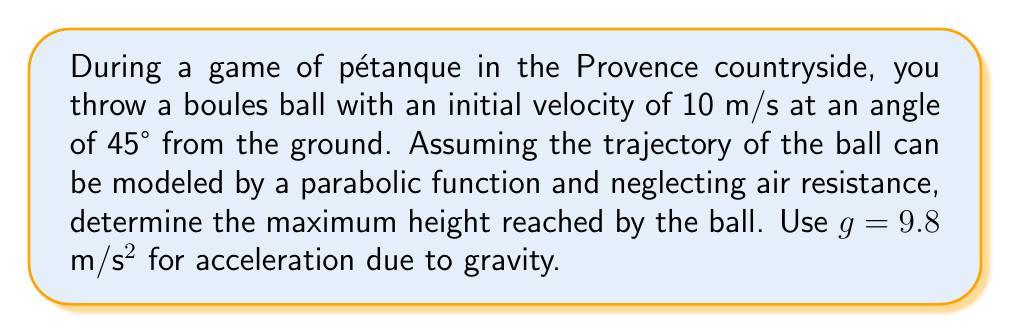Could you help me with this problem? Let's approach this step-by-step:

1) The trajectory of a projectile (like our boules ball) can be described by a parabolic function in the form:

   $$y = -\frac{1}{2}g(\frac{x}{v_x})^2 + \tan(\theta)x + h_0$$

   Where:
   - $y$ is the vertical position
   - $x$ is the horizontal position
   - $g$ is the acceleration due to gravity (9.8 m/s²)
   - $v_x$ is the initial horizontal velocity
   - $\theta$ is the launch angle
   - $h_0$ is the initial height (in this case, 0)

2) We're given:
   - Initial velocity $v = 10$ m/s
   - Launch angle $\theta = 45°$
   - $g = 9.8$ m/s²

3) First, let's calculate the initial horizontal velocity $v_x$:
   $$v_x = v \cos(\theta) = 10 \cos(45°) = 10 \cdot \frac{\sqrt{2}}{2} \approx 7.07 \text{ m/s}$$

4) The maximum height is reached when the vertical velocity becomes zero. At this point, the horizontal distance traveled is half the total range. We don't need to calculate this, as we're only interested in the maximum height.

5) The maximum height can be calculated using the formula:
   $$h_{max} = \frac{v^2 \sin^2(\theta)}{2g}$$

6) Let's substitute our values:
   $$h_{max} = \frac{10^2 \sin^2(45°)}{2(9.8)} = \frac{100 \cdot 0.5}{19.6} \approx 2.55 \text{ m}$$

Therefore, the maximum height reached by the boules ball is approximately 2.55 meters.
Answer: 2.55 m 